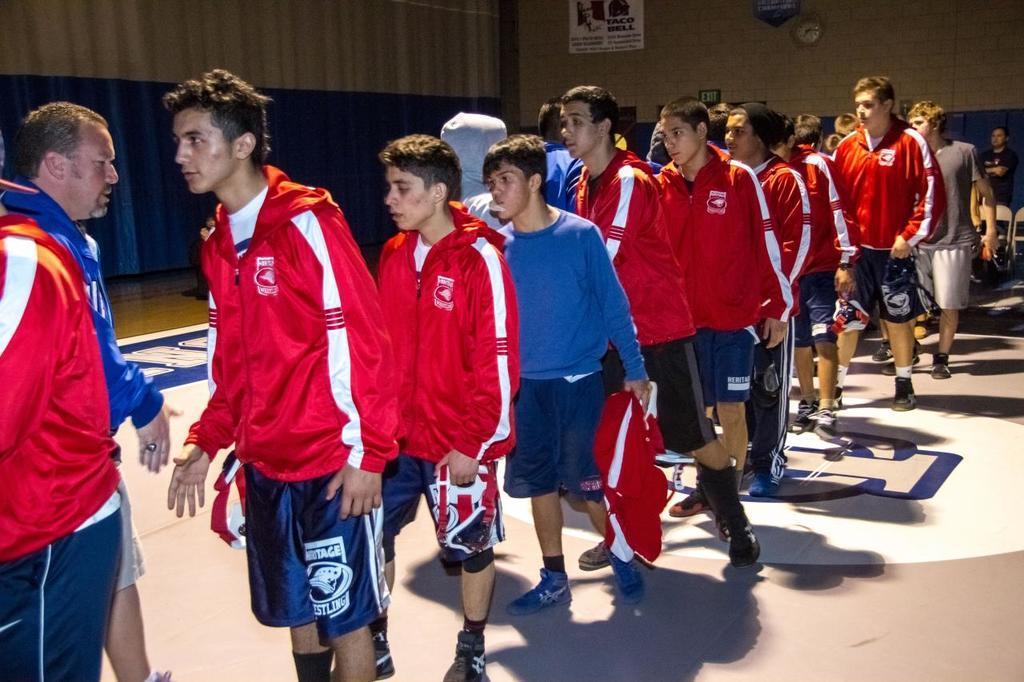Can you describe this image briefly? In this picture we can see a group of people on the ground and in the background we can see a wall, clock and some objects. 